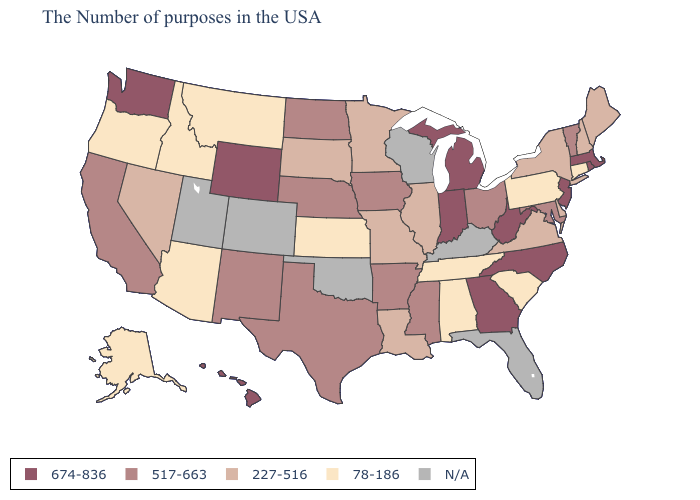Does the map have missing data?
Concise answer only. Yes. Which states have the lowest value in the USA?
Short answer required. Connecticut, Pennsylvania, South Carolina, Alabama, Tennessee, Kansas, Montana, Arizona, Idaho, Oregon, Alaska. Name the states that have a value in the range 674-836?
Quick response, please. Massachusetts, Rhode Island, New Jersey, North Carolina, West Virginia, Georgia, Michigan, Indiana, Wyoming, Washington, Hawaii. How many symbols are there in the legend?
Answer briefly. 5. Does the first symbol in the legend represent the smallest category?
Write a very short answer. No. Name the states that have a value in the range 227-516?
Give a very brief answer. Maine, New Hampshire, New York, Delaware, Virginia, Illinois, Louisiana, Missouri, Minnesota, South Dakota, Nevada. What is the value of Arkansas?
Short answer required. 517-663. Does Oregon have the highest value in the USA?
Be succinct. No. What is the highest value in the West ?
Concise answer only. 674-836. Does the map have missing data?
Keep it brief. Yes. What is the lowest value in the USA?
Be succinct. 78-186. Which states have the highest value in the USA?
Keep it brief. Massachusetts, Rhode Island, New Jersey, North Carolina, West Virginia, Georgia, Michigan, Indiana, Wyoming, Washington, Hawaii. What is the highest value in states that border Minnesota?
Answer briefly. 517-663. Among the states that border Tennessee , does Mississippi have the lowest value?
Short answer required. No. 